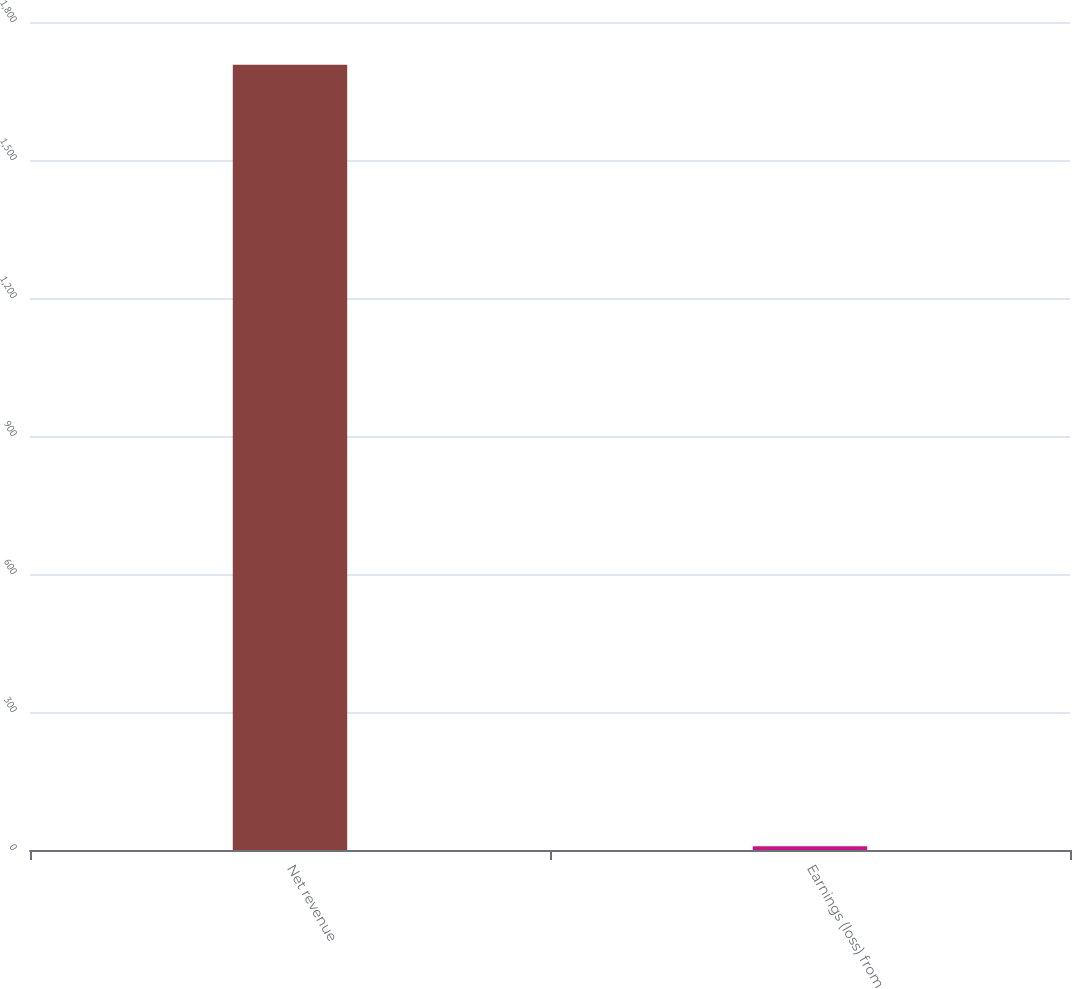Convert chart. <chart><loc_0><loc_0><loc_500><loc_500><bar_chart><fcel>Net revenue<fcel>Earnings (loss) from<nl><fcel>1707<fcel>7.9<nl></chart> 